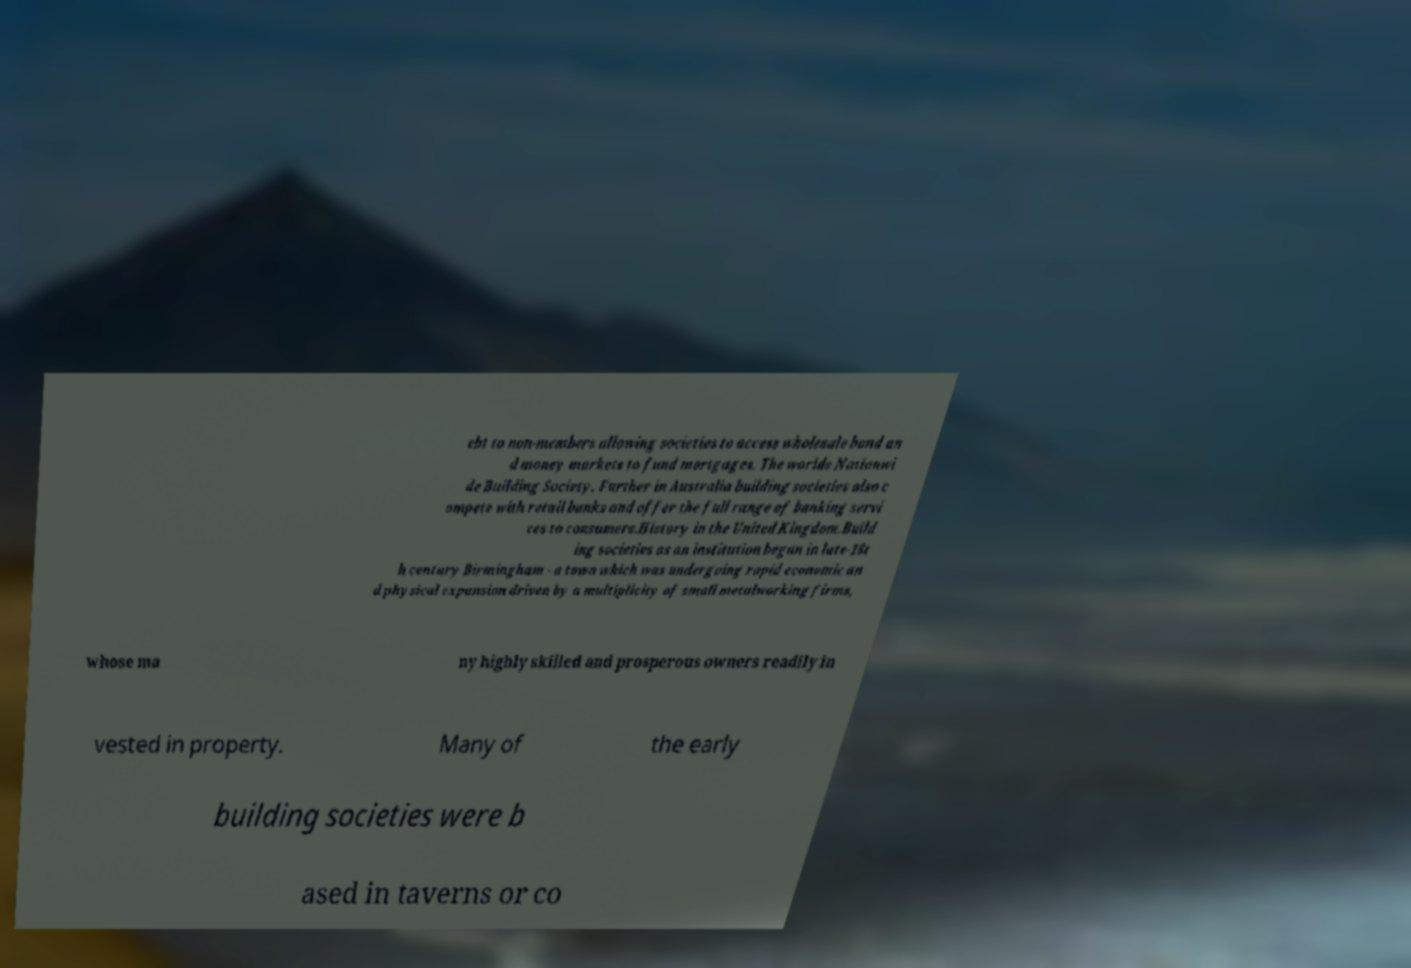What messages or text are displayed in this image? I need them in a readable, typed format. ebt to non-members allowing societies to access wholesale bond an d money markets to fund mortgages. The worlds Nationwi de Building Society. Further in Australia building societies also c ompete with retail banks and offer the full range of banking servi ces to consumers.History in the United Kingdom.Build ing societies as an institution began in late-18t h century Birmingham - a town which was undergoing rapid economic an d physical expansion driven by a multiplicity of small metalworking firms, whose ma ny highly skilled and prosperous owners readily in vested in property. Many of the early building societies were b ased in taverns or co 